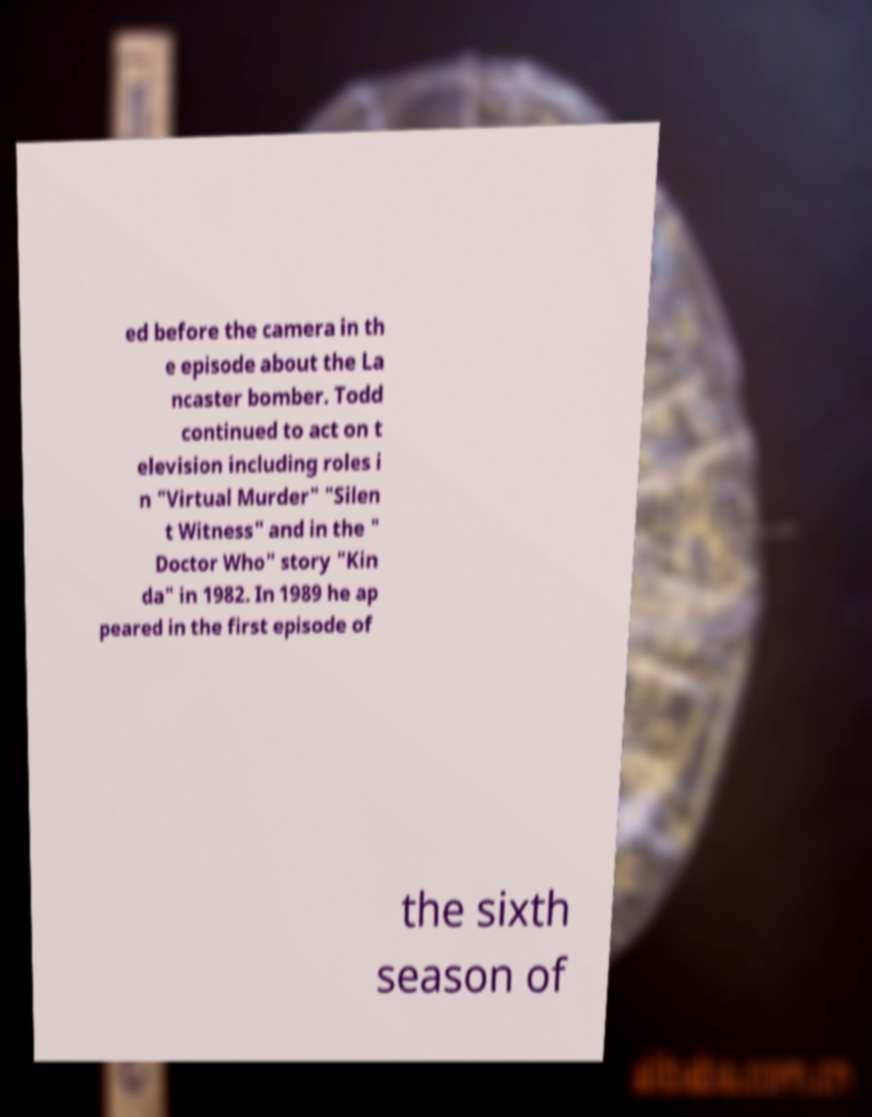I need the written content from this picture converted into text. Can you do that? ed before the camera in th e episode about the La ncaster bomber. Todd continued to act on t elevision including roles i n "Virtual Murder" "Silen t Witness" and in the " Doctor Who" story "Kin da" in 1982. In 1989 he ap peared in the first episode of the sixth season of 